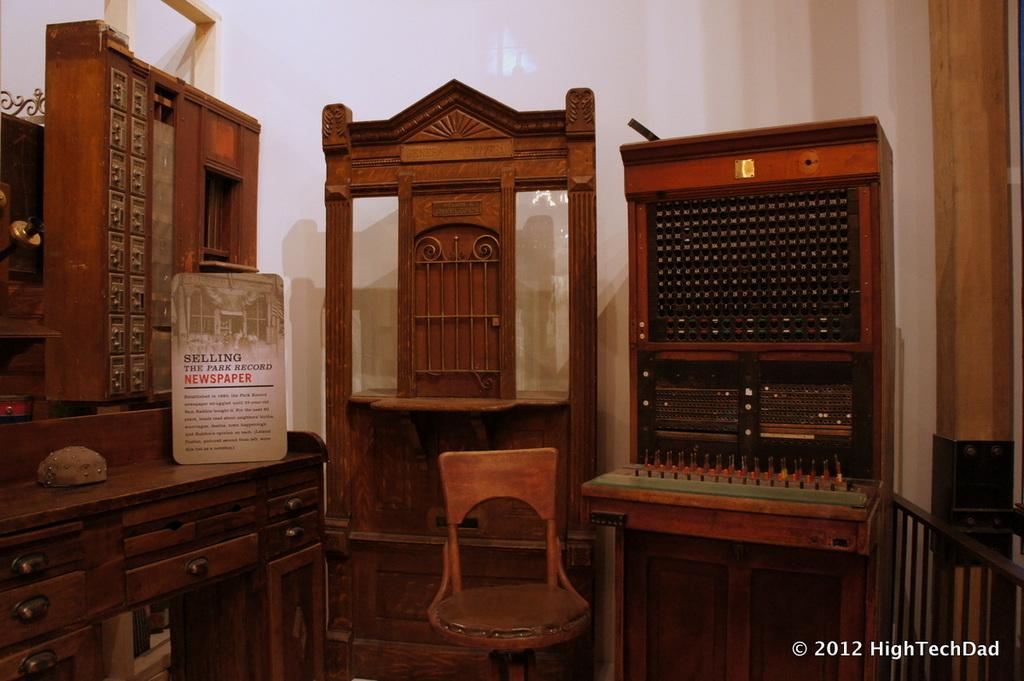What is the main object in the center of the image? There is a chair in the center of the image. Can you describe any other furniture items visible in the image? There are furniture items visible at the back side of the image. How many dogs are sitting on the chair in the image? There are no dogs present in the image; it only features a chair and other furniture items. 